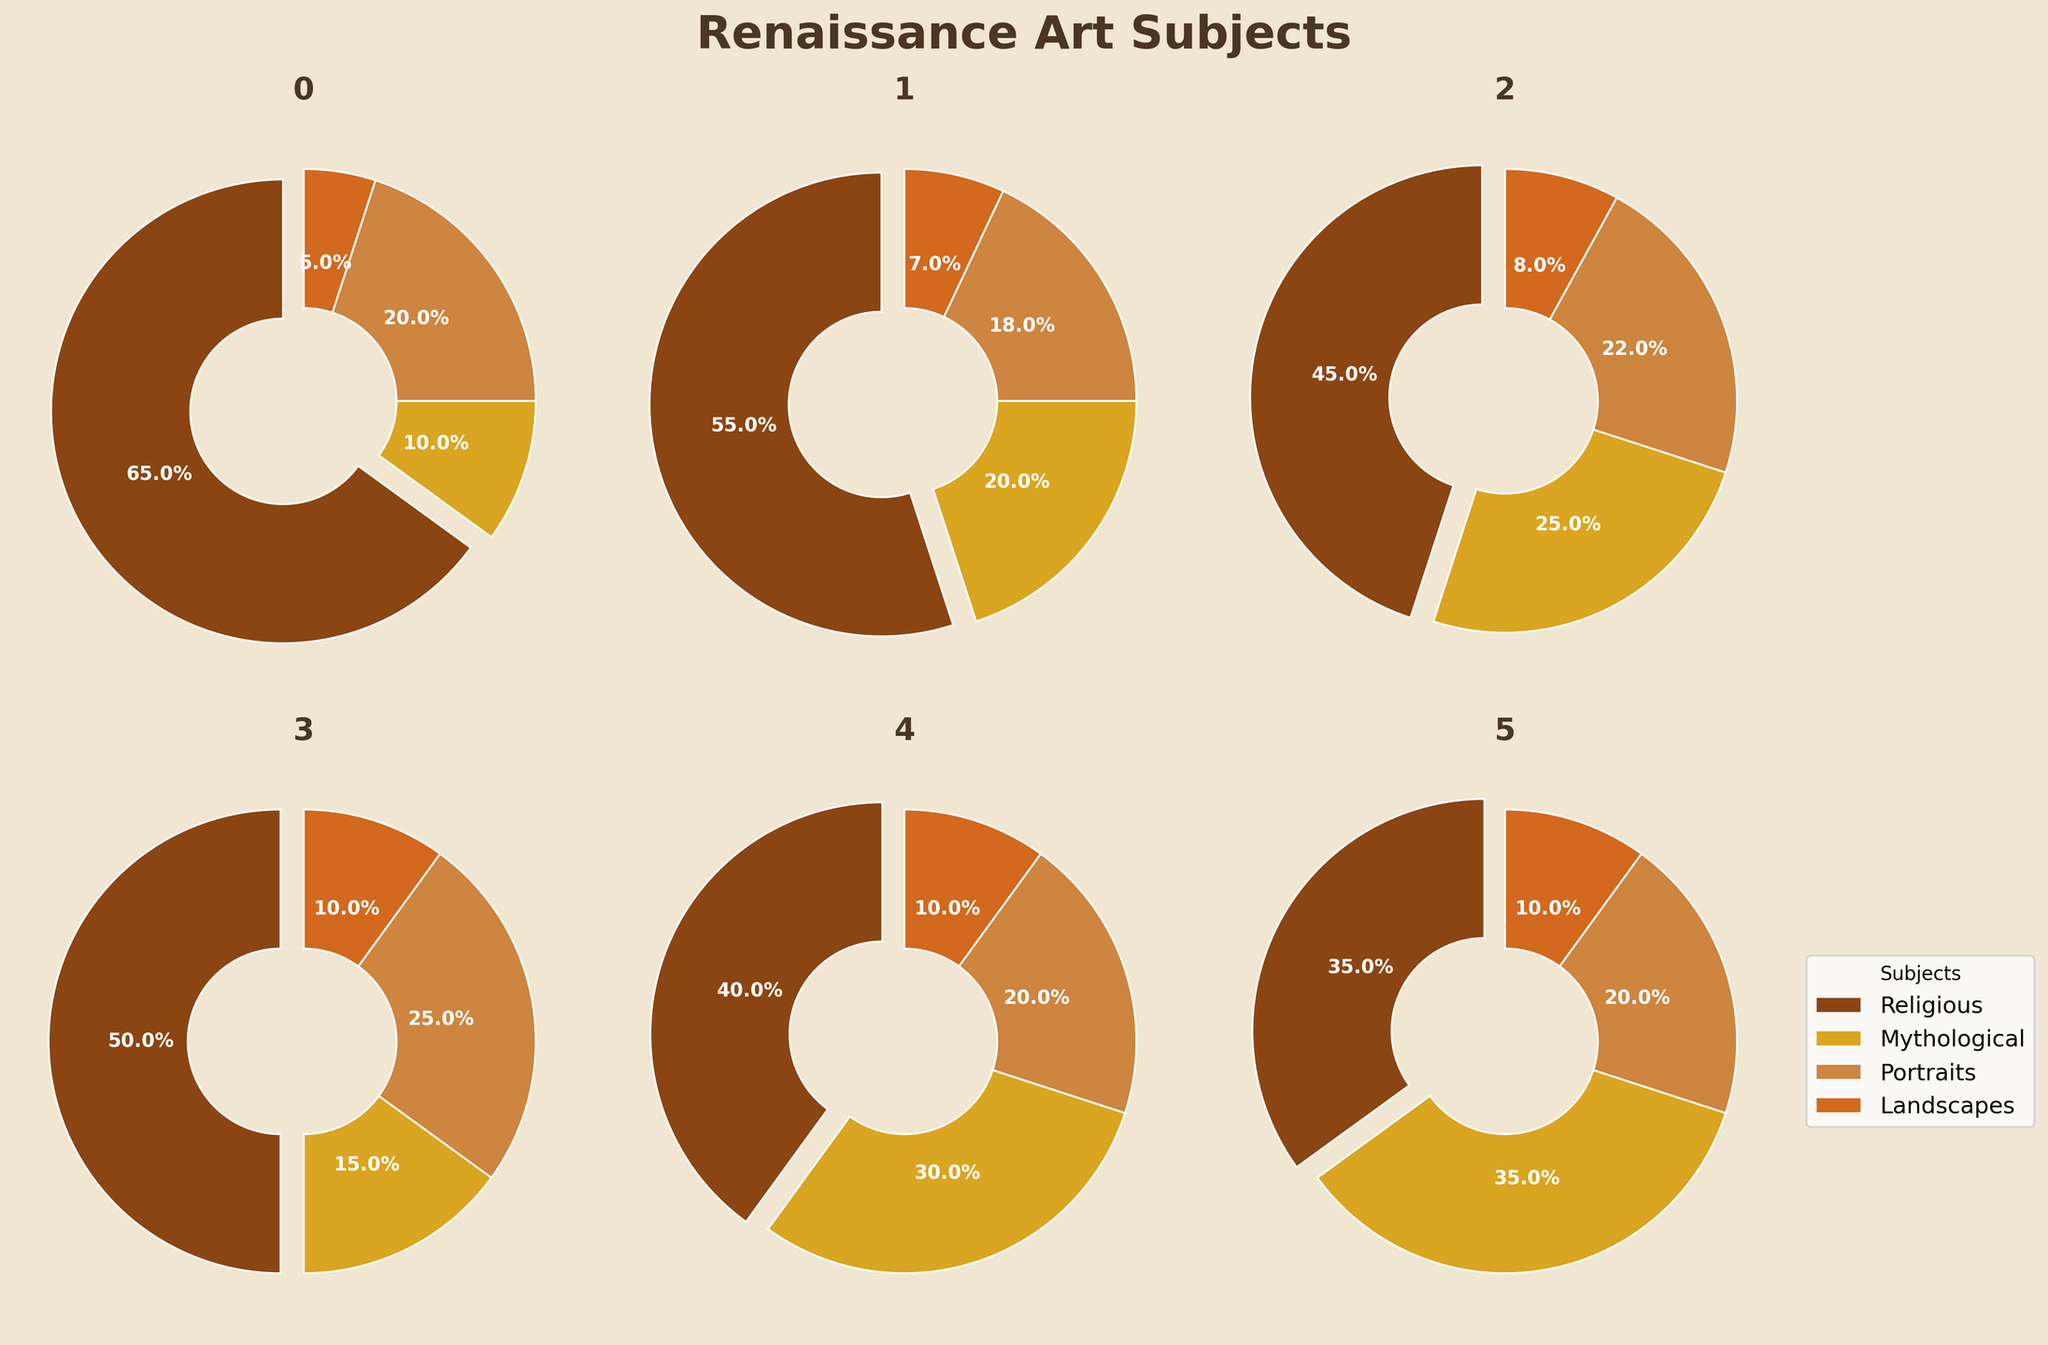How does the proportion of Mythological subjects in the Mannerism period compare to that in the High Renaissance period? The proportion of Mythological subjects in the Mannerism period is 35%, and in the High Renaissance period it is 20%. Clearly, the Mannerism period has a higher proportion of Mythological subjects compared to the High Renaissance period.
Answer: Mannerism has a higher proportion Which period has the lowest proportion of Religious subjects, and what is this proportion? The Venetian Renaissance period has the lowest proportion of Religious subjects, which is 40%. This is obtained by comparing the values of Religious subjects across all periods.
Answer: Venetian Renaissance, 40% What is the average proportion of Portraits subjects across all periods? To find the average, sum the proportions of Portraits subjects across all periods and divide by the number of periods. The sum is (20 + 18 + 22 + 25 + 20 + 20) = 125, and the number of periods is 6. Therefore, the average is 125/6 ≈ 20.83%.
Answer: 20.83% In which period do Landscapes subjects achieve their highest proportion, and what is this proportion? The highest proportion of Landscapes subjects is achieved during the Northern and Venetian Renaissance periods, both at 10%.
Answer: Northern Renaissance and Venetian Renaissance, 10% How does the proportion of Religious subjects change from the Early Renaissance to the Late Renaissance? The proportion of Religious subjects decreases from 65% in the Early Renaissance to 45% in the Late Renaissance. This is a decrease of 20 percentage points.
Answer: Decreases by 20% Which subject category is the most consistent in its proportion across all periods? The Landscapes subject category is the most consistent, ranging from 5% to 10% across all periods. This relatively small range indicates consistency in its proportion.
Answer: Landscapes Calculate the total percentage of Mythological and Portraits subjects in the High Renaissance period. Adding the proportions of Mythological (20%) and Portraits (18%) subjects in the High Renaissance period, the total is 20% + 18% = 38%.
Answer: 38% What is the difference between the highest and lowest proportions of subjects in the Mannerism period? The highest proportion in the Mannerism period is Mythological subjects at 35%, and the lowest is Land at 10%. The difference is 35% - 10% = 25%.
Answer: 25% In which period does the combined proportion of Religious and Landscapes subjects equal 50%? Summing the proportions for each period: For the Early Renaissance (65% + 5% = 70%), High Renaissance (55% + 7% = 62%), Late Renaissance (45% + 8% = 53%), Northern Renaissance (50% + 10% = 60%), Venetian Renaissance (40% + 10% = 50%), Mannerism (35% + 10% = 45%). Therefore, the Venetian Renaissance period has a combined proportion of 50%.
Answer: Venetian Renaissance 